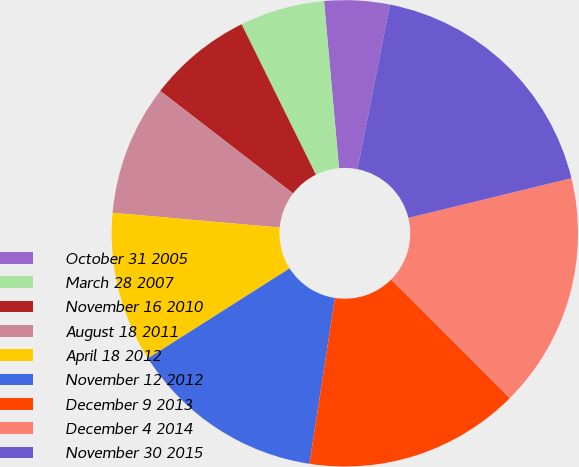Convert chart. <chart><loc_0><loc_0><loc_500><loc_500><pie_chart><fcel>October 31 2005<fcel>March 28 2007<fcel>November 16 2010<fcel>August 18 2011<fcel>April 18 2012<fcel>November 12 2012<fcel>December 9 2013<fcel>December 4 2014<fcel>November 30 2015<nl><fcel>4.52%<fcel>5.88%<fcel>7.24%<fcel>9.05%<fcel>10.41%<fcel>13.57%<fcel>14.93%<fcel>16.29%<fcel>18.1%<nl></chart> 